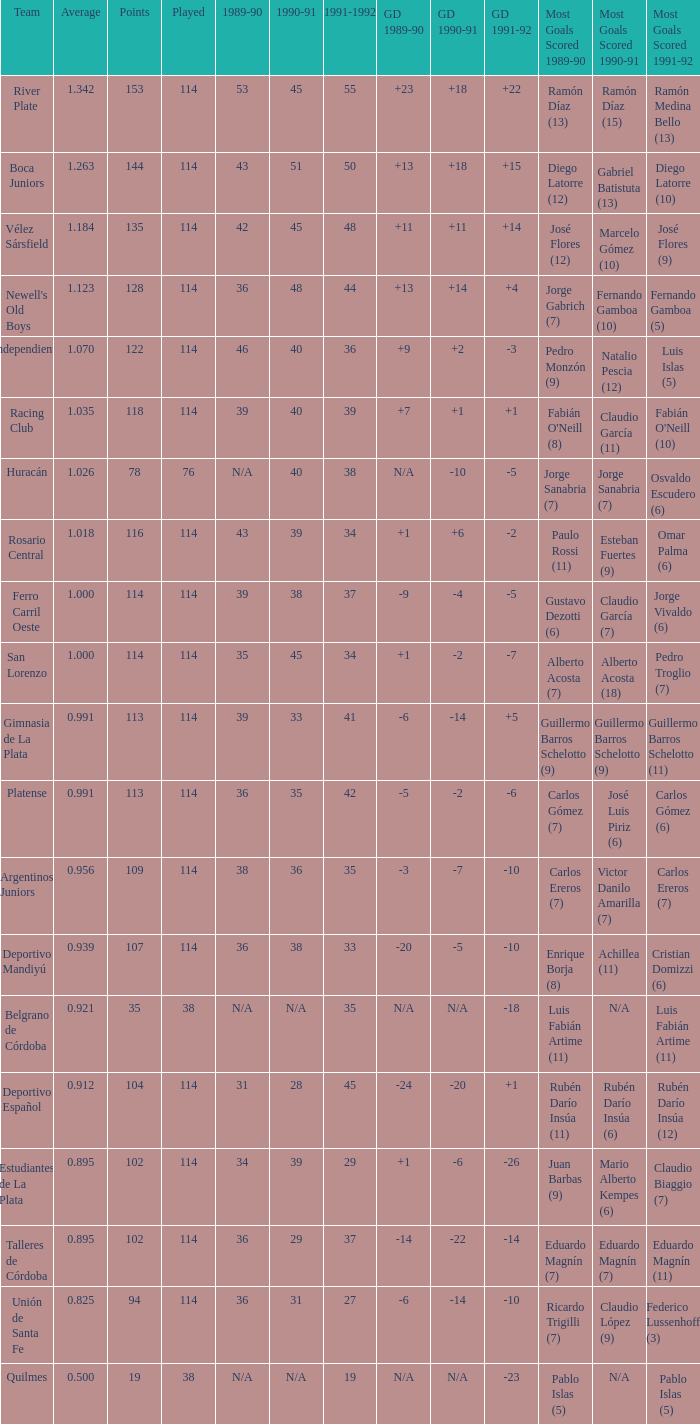How much Played has an Average smaller than 0.9390000000000001, and a 1990-91 of 28? 1.0. 